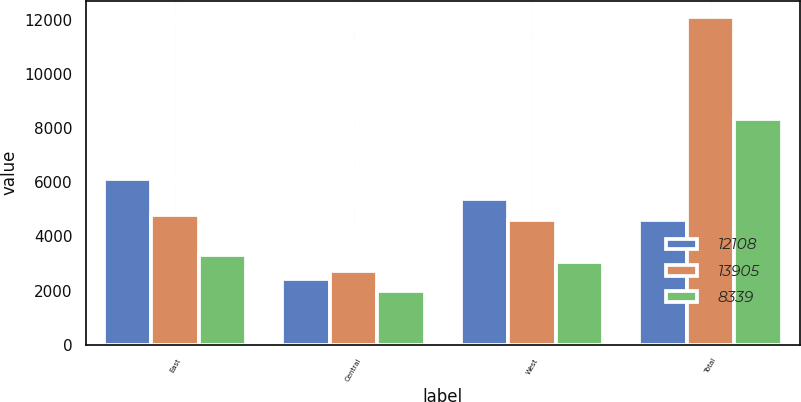<chart> <loc_0><loc_0><loc_500><loc_500><stacked_bar_chart><ecel><fcel>East<fcel>Central<fcel>West<fcel>Total<nl><fcel>12108<fcel>6121<fcel>2416<fcel>5368<fcel>4615<nl><fcel>13905<fcel>4780<fcel>2713<fcel>4615<fcel>12108<nl><fcel>8339<fcel>3314<fcel>1977<fcel>3048<fcel>8339<nl></chart> 